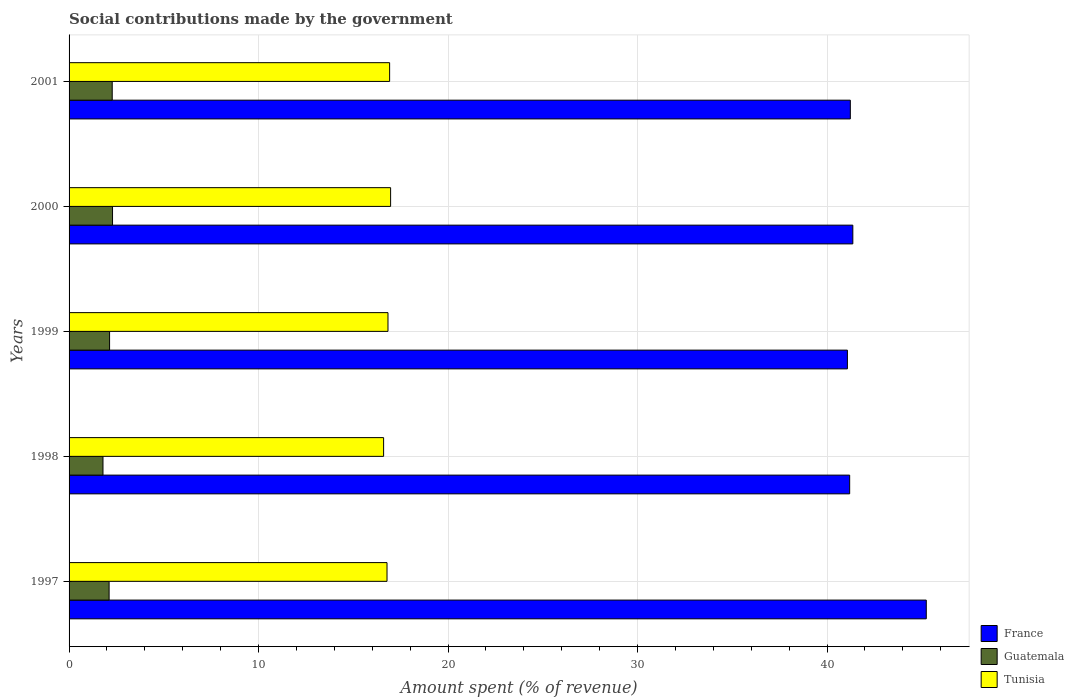How many different coloured bars are there?
Your answer should be very brief. 3. Are the number of bars per tick equal to the number of legend labels?
Offer a very short reply. Yes. Are the number of bars on each tick of the Y-axis equal?
Your answer should be compact. Yes. What is the label of the 2nd group of bars from the top?
Keep it short and to the point. 2000. What is the amount spent (in %) on social contributions in Tunisia in 1997?
Provide a succinct answer. 16.78. Across all years, what is the maximum amount spent (in %) on social contributions in Tunisia?
Provide a succinct answer. 16.97. Across all years, what is the minimum amount spent (in %) on social contributions in Guatemala?
Your answer should be very brief. 1.79. In which year was the amount spent (in %) on social contributions in Tunisia minimum?
Your answer should be compact. 1998. What is the total amount spent (in %) on social contributions in Tunisia in the graph?
Keep it short and to the point. 84.1. What is the difference between the amount spent (in %) on social contributions in Guatemala in 1999 and that in 2000?
Provide a short and direct response. -0.16. What is the difference between the amount spent (in %) on social contributions in Tunisia in 1998 and the amount spent (in %) on social contributions in France in 2001?
Your response must be concise. -24.63. What is the average amount spent (in %) on social contributions in Guatemala per year?
Your answer should be compact. 2.12. In the year 1997, what is the difference between the amount spent (in %) on social contributions in Guatemala and amount spent (in %) on social contributions in France?
Your response must be concise. -43.13. In how many years, is the amount spent (in %) on social contributions in Guatemala greater than 34 %?
Provide a succinct answer. 0. What is the ratio of the amount spent (in %) on social contributions in France in 1997 to that in 1999?
Your answer should be compact. 1.1. Is the amount spent (in %) on social contributions in Guatemala in 1998 less than that in 2000?
Ensure brevity in your answer.  Yes. Is the difference between the amount spent (in %) on social contributions in Guatemala in 1997 and 2001 greater than the difference between the amount spent (in %) on social contributions in France in 1997 and 2001?
Your answer should be very brief. No. What is the difference between the highest and the second highest amount spent (in %) on social contributions in Guatemala?
Provide a short and direct response. 0.02. What is the difference between the highest and the lowest amount spent (in %) on social contributions in Tunisia?
Provide a succinct answer. 0.37. What does the 3rd bar from the top in 2001 represents?
Provide a short and direct response. France. What does the 3rd bar from the bottom in 2001 represents?
Give a very brief answer. Tunisia. Is it the case that in every year, the sum of the amount spent (in %) on social contributions in Guatemala and amount spent (in %) on social contributions in France is greater than the amount spent (in %) on social contributions in Tunisia?
Offer a very short reply. Yes. Are all the bars in the graph horizontal?
Make the answer very short. Yes. How many years are there in the graph?
Ensure brevity in your answer.  5. Are the values on the major ticks of X-axis written in scientific E-notation?
Your answer should be compact. No. Does the graph contain any zero values?
Your answer should be compact. No. Where does the legend appear in the graph?
Offer a terse response. Bottom right. How many legend labels are there?
Make the answer very short. 3. How are the legend labels stacked?
Provide a succinct answer. Vertical. What is the title of the graph?
Offer a terse response. Social contributions made by the government. What is the label or title of the X-axis?
Make the answer very short. Amount spent (% of revenue). What is the Amount spent (% of revenue) in France in 1997?
Your answer should be very brief. 45.24. What is the Amount spent (% of revenue) in Guatemala in 1997?
Ensure brevity in your answer.  2.11. What is the Amount spent (% of revenue) in Tunisia in 1997?
Your answer should be compact. 16.78. What is the Amount spent (% of revenue) in France in 1998?
Make the answer very short. 41.2. What is the Amount spent (% of revenue) in Guatemala in 1998?
Give a very brief answer. 1.79. What is the Amount spent (% of revenue) in Tunisia in 1998?
Offer a very short reply. 16.6. What is the Amount spent (% of revenue) of France in 1999?
Ensure brevity in your answer.  41.08. What is the Amount spent (% of revenue) in Guatemala in 1999?
Give a very brief answer. 2.14. What is the Amount spent (% of revenue) in Tunisia in 1999?
Give a very brief answer. 16.83. What is the Amount spent (% of revenue) of France in 2000?
Offer a terse response. 41.36. What is the Amount spent (% of revenue) of Guatemala in 2000?
Ensure brevity in your answer.  2.29. What is the Amount spent (% of revenue) of Tunisia in 2000?
Give a very brief answer. 16.97. What is the Amount spent (% of revenue) of France in 2001?
Provide a short and direct response. 41.23. What is the Amount spent (% of revenue) of Guatemala in 2001?
Provide a succinct answer. 2.28. What is the Amount spent (% of revenue) of Tunisia in 2001?
Ensure brevity in your answer.  16.92. Across all years, what is the maximum Amount spent (% of revenue) of France?
Provide a succinct answer. 45.24. Across all years, what is the maximum Amount spent (% of revenue) of Guatemala?
Give a very brief answer. 2.29. Across all years, what is the maximum Amount spent (% of revenue) of Tunisia?
Make the answer very short. 16.97. Across all years, what is the minimum Amount spent (% of revenue) of France?
Provide a short and direct response. 41.08. Across all years, what is the minimum Amount spent (% of revenue) of Guatemala?
Keep it short and to the point. 1.79. Across all years, what is the minimum Amount spent (% of revenue) in Tunisia?
Provide a succinct answer. 16.6. What is the total Amount spent (% of revenue) of France in the graph?
Offer a very short reply. 210.11. What is the total Amount spent (% of revenue) in Guatemala in the graph?
Your answer should be compact. 10.61. What is the total Amount spent (% of revenue) of Tunisia in the graph?
Offer a terse response. 84.1. What is the difference between the Amount spent (% of revenue) in France in 1997 and that in 1998?
Your answer should be very brief. 4.04. What is the difference between the Amount spent (% of revenue) of Guatemala in 1997 and that in 1998?
Make the answer very short. 0.32. What is the difference between the Amount spent (% of revenue) in Tunisia in 1997 and that in 1998?
Keep it short and to the point. 0.18. What is the difference between the Amount spent (% of revenue) in France in 1997 and that in 1999?
Provide a succinct answer. 4.16. What is the difference between the Amount spent (% of revenue) of Guatemala in 1997 and that in 1999?
Your response must be concise. -0.03. What is the difference between the Amount spent (% of revenue) in Tunisia in 1997 and that in 1999?
Offer a very short reply. -0.05. What is the difference between the Amount spent (% of revenue) in France in 1997 and that in 2000?
Keep it short and to the point. 3.88. What is the difference between the Amount spent (% of revenue) of Guatemala in 1997 and that in 2000?
Provide a succinct answer. -0.18. What is the difference between the Amount spent (% of revenue) of Tunisia in 1997 and that in 2000?
Keep it short and to the point. -0.19. What is the difference between the Amount spent (% of revenue) in France in 1997 and that in 2001?
Ensure brevity in your answer.  4.01. What is the difference between the Amount spent (% of revenue) of Guatemala in 1997 and that in 2001?
Give a very brief answer. -0.16. What is the difference between the Amount spent (% of revenue) of Tunisia in 1997 and that in 2001?
Provide a succinct answer. -0.14. What is the difference between the Amount spent (% of revenue) in France in 1998 and that in 1999?
Offer a very short reply. 0.12. What is the difference between the Amount spent (% of revenue) in Guatemala in 1998 and that in 1999?
Your response must be concise. -0.35. What is the difference between the Amount spent (% of revenue) in Tunisia in 1998 and that in 1999?
Give a very brief answer. -0.23. What is the difference between the Amount spent (% of revenue) of France in 1998 and that in 2000?
Give a very brief answer. -0.17. What is the difference between the Amount spent (% of revenue) in Guatemala in 1998 and that in 2000?
Your answer should be compact. -0.5. What is the difference between the Amount spent (% of revenue) of Tunisia in 1998 and that in 2000?
Ensure brevity in your answer.  -0.37. What is the difference between the Amount spent (% of revenue) in France in 1998 and that in 2001?
Make the answer very short. -0.03. What is the difference between the Amount spent (% of revenue) of Guatemala in 1998 and that in 2001?
Ensure brevity in your answer.  -0.49. What is the difference between the Amount spent (% of revenue) in Tunisia in 1998 and that in 2001?
Keep it short and to the point. -0.32. What is the difference between the Amount spent (% of revenue) of France in 1999 and that in 2000?
Provide a succinct answer. -0.29. What is the difference between the Amount spent (% of revenue) of Guatemala in 1999 and that in 2000?
Provide a succinct answer. -0.16. What is the difference between the Amount spent (% of revenue) of Tunisia in 1999 and that in 2000?
Make the answer very short. -0.14. What is the difference between the Amount spent (% of revenue) of France in 1999 and that in 2001?
Your response must be concise. -0.15. What is the difference between the Amount spent (% of revenue) in Guatemala in 1999 and that in 2001?
Keep it short and to the point. -0.14. What is the difference between the Amount spent (% of revenue) in Tunisia in 1999 and that in 2001?
Offer a very short reply. -0.09. What is the difference between the Amount spent (% of revenue) in France in 2000 and that in 2001?
Ensure brevity in your answer.  0.13. What is the difference between the Amount spent (% of revenue) of Guatemala in 2000 and that in 2001?
Ensure brevity in your answer.  0.02. What is the difference between the Amount spent (% of revenue) of Tunisia in 2000 and that in 2001?
Offer a terse response. 0.05. What is the difference between the Amount spent (% of revenue) of France in 1997 and the Amount spent (% of revenue) of Guatemala in 1998?
Give a very brief answer. 43.45. What is the difference between the Amount spent (% of revenue) in France in 1997 and the Amount spent (% of revenue) in Tunisia in 1998?
Provide a succinct answer. 28.64. What is the difference between the Amount spent (% of revenue) in Guatemala in 1997 and the Amount spent (% of revenue) in Tunisia in 1998?
Offer a terse response. -14.49. What is the difference between the Amount spent (% of revenue) of France in 1997 and the Amount spent (% of revenue) of Guatemala in 1999?
Give a very brief answer. 43.1. What is the difference between the Amount spent (% of revenue) in France in 1997 and the Amount spent (% of revenue) in Tunisia in 1999?
Provide a succinct answer. 28.41. What is the difference between the Amount spent (% of revenue) in Guatemala in 1997 and the Amount spent (% of revenue) in Tunisia in 1999?
Your answer should be very brief. -14.72. What is the difference between the Amount spent (% of revenue) of France in 1997 and the Amount spent (% of revenue) of Guatemala in 2000?
Ensure brevity in your answer.  42.95. What is the difference between the Amount spent (% of revenue) of France in 1997 and the Amount spent (% of revenue) of Tunisia in 2000?
Make the answer very short. 28.27. What is the difference between the Amount spent (% of revenue) in Guatemala in 1997 and the Amount spent (% of revenue) in Tunisia in 2000?
Your answer should be compact. -14.86. What is the difference between the Amount spent (% of revenue) of France in 1997 and the Amount spent (% of revenue) of Guatemala in 2001?
Ensure brevity in your answer.  42.96. What is the difference between the Amount spent (% of revenue) of France in 1997 and the Amount spent (% of revenue) of Tunisia in 2001?
Your answer should be compact. 28.32. What is the difference between the Amount spent (% of revenue) of Guatemala in 1997 and the Amount spent (% of revenue) of Tunisia in 2001?
Ensure brevity in your answer.  -14.8. What is the difference between the Amount spent (% of revenue) in France in 1998 and the Amount spent (% of revenue) in Guatemala in 1999?
Your response must be concise. 39.06. What is the difference between the Amount spent (% of revenue) in France in 1998 and the Amount spent (% of revenue) in Tunisia in 1999?
Provide a succinct answer. 24.37. What is the difference between the Amount spent (% of revenue) in Guatemala in 1998 and the Amount spent (% of revenue) in Tunisia in 1999?
Keep it short and to the point. -15.04. What is the difference between the Amount spent (% of revenue) of France in 1998 and the Amount spent (% of revenue) of Guatemala in 2000?
Make the answer very short. 38.9. What is the difference between the Amount spent (% of revenue) of France in 1998 and the Amount spent (% of revenue) of Tunisia in 2000?
Make the answer very short. 24.23. What is the difference between the Amount spent (% of revenue) in Guatemala in 1998 and the Amount spent (% of revenue) in Tunisia in 2000?
Make the answer very short. -15.18. What is the difference between the Amount spent (% of revenue) in France in 1998 and the Amount spent (% of revenue) in Guatemala in 2001?
Your answer should be very brief. 38.92. What is the difference between the Amount spent (% of revenue) of France in 1998 and the Amount spent (% of revenue) of Tunisia in 2001?
Make the answer very short. 24.28. What is the difference between the Amount spent (% of revenue) of Guatemala in 1998 and the Amount spent (% of revenue) of Tunisia in 2001?
Keep it short and to the point. -15.13. What is the difference between the Amount spent (% of revenue) of France in 1999 and the Amount spent (% of revenue) of Guatemala in 2000?
Offer a very short reply. 38.78. What is the difference between the Amount spent (% of revenue) of France in 1999 and the Amount spent (% of revenue) of Tunisia in 2000?
Offer a terse response. 24.11. What is the difference between the Amount spent (% of revenue) in Guatemala in 1999 and the Amount spent (% of revenue) in Tunisia in 2000?
Your response must be concise. -14.83. What is the difference between the Amount spent (% of revenue) of France in 1999 and the Amount spent (% of revenue) of Guatemala in 2001?
Provide a short and direct response. 38.8. What is the difference between the Amount spent (% of revenue) in France in 1999 and the Amount spent (% of revenue) in Tunisia in 2001?
Offer a very short reply. 24.16. What is the difference between the Amount spent (% of revenue) of Guatemala in 1999 and the Amount spent (% of revenue) of Tunisia in 2001?
Provide a short and direct response. -14.78. What is the difference between the Amount spent (% of revenue) of France in 2000 and the Amount spent (% of revenue) of Guatemala in 2001?
Your answer should be compact. 39.09. What is the difference between the Amount spent (% of revenue) in France in 2000 and the Amount spent (% of revenue) in Tunisia in 2001?
Give a very brief answer. 24.45. What is the difference between the Amount spent (% of revenue) of Guatemala in 2000 and the Amount spent (% of revenue) of Tunisia in 2001?
Give a very brief answer. -14.62. What is the average Amount spent (% of revenue) of France per year?
Make the answer very short. 42.02. What is the average Amount spent (% of revenue) in Guatemala per year?
Your response must be concise. 2.12. What is the average Amount spent (% of revenue) in Tunisia per year?
Offer a very short reply. 16.82. In the year 1997, what is the difference between the Amount spent (% of revenue) in France and Amount spent (% of revenue) in Guatemala?
Offer a very short reply. 43.13. In the year 1997, what is the difference between the Amount spent (% of revenue) of France and Amount spent (% of revenue) of Tunisia?
Give a very brief answer. 28.46. In the year 1997, what is the difference between the Amount spent (% of revenue) in Guatemala and Amount spent (% of revenue) in Tunisia?
Keep it short and to the point. -14.67. In the year 1998, what is the difference between the Amount spent (% of revenue) of France and Amount spent (% of revenue) of Guatemala?
Your answer should be compact. 39.41. In the year 1998, what is the difference between the Amount spent (% of revenue) of France and Amount spent (% of revenue) of Tunisia?
Provide a short and direct response. 24.6. In the year 1998, what is the difference between the Amount spent (% of revenue) in Guatemala and Amount spent (% of revenue) in Tunisia?
Provide a succinct answer. -14.81. In the year 1999, what is the difference between the Amount spent (% of revenue) in France and Amount spent (% of revenue) in Guatemala?
Offer a very short reply. 38.94. In the year 1999, what is the difference between the Amount spent (% of revenue) of France and Amount spent (% of revenue) of Tunisia?
Your response must be concise. 24.25. In the year 1999, what is the difference between the Amount spent (% of revenue) in Guatemala and Amount spent (% of revenue) in Tunisia?
Provide a succinct answer. -14.69. In the year 2000, what is the difference between the Amount spent (% of revenue) of France and Amount spent (% of revenue) of Guatemala?
Provide a short and direct response. 39.07. In the year 2000, what is the difference between the Amount spent (% of revenue) of France and Amount spent (% of revenue) of Tunisia?
Give a very brief answer. 24.39. In the year 2000, what is the difference between the Amount spent (% of revenue) of Guatemala and Amount spent (% of revenue) of Tunisia?
Give a very brief answer. -14.68. In the year 2001, what is the difference between the Amount spent (% of revenue) in France and Amount spent (% of revenue) in Guatemala?
Offer a very short reply. 38.95. In the year 2001, what is the difference between the Amount spent (% of revenue) of France and Amount spent (% of revenue) of Tunisia?
Offer a terse response. 24.31. In the year 2001, what is the difference between the Amount spent (% of revenue) of Guatemala and Amount spent (% of revenue) of Tunisia?
Keep it short and to the point. -14.64. What is the ratio of the Amount spent (% of revenue) in France in 1997 to that in 1998?
Your response must be concise. 1.1. What is the ratio of the Amount spent (% of revenue) in Guatemala in 1997 to that in 1998?
Give a very brief answer. 1.18. What is the ratio of the Amount spent (% of revenue) of Tunisia in 1997 to that in 1998?
Your answer should be very brief. 1.01. What is the ratio of the Amount spent (% of revenue) in France in 1997 to that in 1999?
Offer a terse response. 1.1. What is the ratio of the Amount spent (% of revenue) in Tunisia in 1997 to that in 1999?
Your answer should be compact. 1. What is the ratio of the Amount spent (% of revenue) of France in 1997 to that in 2000?
Offer a terse response. 1.09. What is the ratio of the Amount spent (% of revenue) in Guatemala in 1997 to that in 2000?
Make the answer very short. 0.92. What is the ratio of the Amount spent (% of revenue) in France in 1997 to that in 2001?
Your answer should be compact. 1.1. What is the ratio of the Amount spent (% of revenue) of Guatemala in 1997 to that in 2001?
Keep it short and to the point. 0.93. What is the ratio of the Amount spent (% of revenue) of France in 1998 to that in 1999?
Ensure brevity in your answer.  1. What is the ratio of the Amount spent (% of revenue) of Guatemala in 1998 to that in 1999?
Keep it short and to the point. 0.84. What is the ratio of the Amount spent (% of revenue) in Tunisia in 1998 to that in 1999?
Offer a terse response. 0.99. What is the ratio of the Amount spent (% of revenue) in France in 1998 to that in 2000?
Provide a succinct answer. 1. What is the ratio of the Amount spent (% of revenue) in Guatemala in 1998 to that in 2000?
Provide a short and direct response. 0.78. What is the ratio of the Amount spent (% of revenue) of Tunisia in 1998 to that in 2000?
Your answer should be compact. 0.98. What is the ratio of the Amount spent (% of revenue) in France in 1998 to that in 2001?
Provide a short and direct response. 1. What is the ratio of the Amount spent (% of revenue) of Guatemala in 1998 to that in 2001?
Your answer should be very brief. 0.79. What is the ratio of the Amount spent (% of revenue) of Tunisia in 1998 to that in 2001?
Provide a succinct answer. 0.98. What is the ratio of the Amount spent (% of revenue) of Guatemala in 1999 to that in 2000?
Your answer should be compact. 0.93. What is the ratio of the Amount spent (% of revenue) of France in 1999 to that in 2001?
Your answer should be compact. 1. What is the ratio of the Amount spent (% of revenue) of Guatemala in 1999 to that in 2001?
Provide a succinct answer. 0.94. What is the ratio of the Amount spent (% of revenue) of Tunisia in 1999 to that in 2001?
Give a very brief answer. 0.99. What is the ratio of the Amount spent (% of revenue) in Guatemala in 2000 to that in 2001?
Provide a succinct answer. 1.01. What is the difference between the highest and the second highest Amount spent (% of revenue) in France?
Provide a succinct answer. 3.88. What is the difference between the highest and the second highest Amount spent (% of revenue) of Guatemala?
Your answer should be very brief. 0.02. What is the difference between the highest and the second highest Amount spent (% of revenue) of Tunisia?
Your response must be concise. 0.05. What is the difference between the highest and the lowest Amount spent (% of revenue) in France?
Offer a very short reply. 4.16. What is the difference between the highest and the lowest Amount spent (% of revenue) of Guatemala?
Your response must be concise. 0.5. What is the difference between the highest and the lowest Amount spent (% of revenue) in Tunisia?
Ensure brevity in your answer.  0.37. 